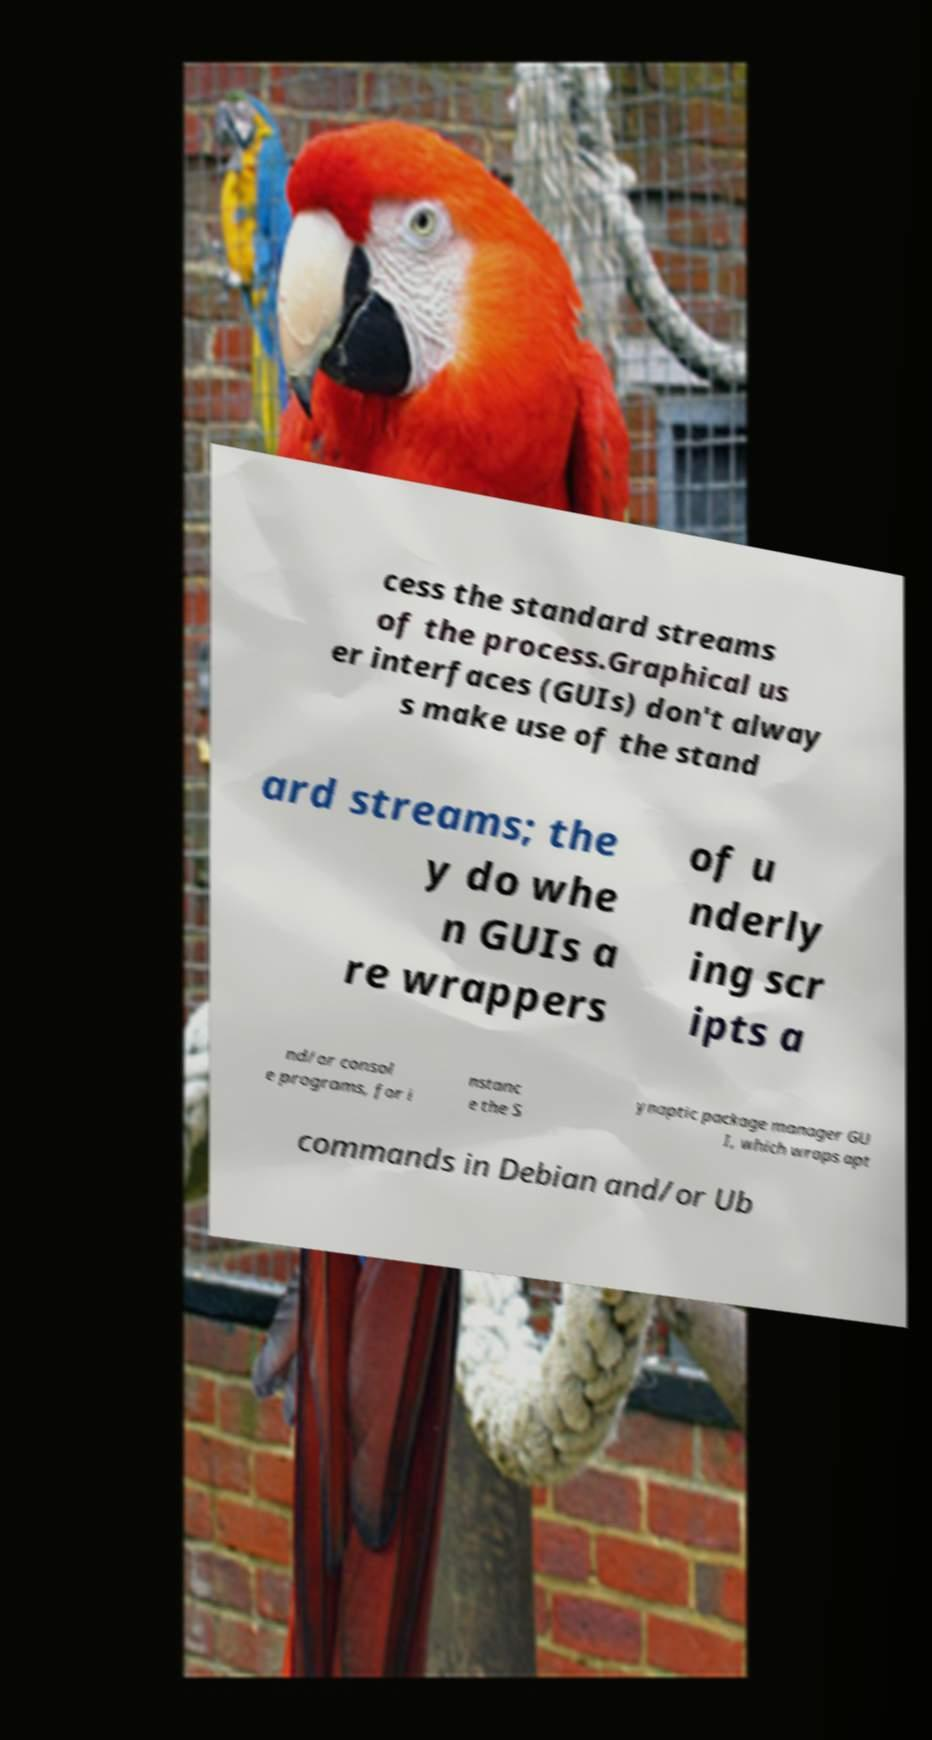What messages or text are displayed in this image? I need them in a readable, typed format. cess the standard streams of the process.Graphical us er interfaces (GUIs) don't alway s make use of the stand ard streams; the y do whe n GUIs a re wrappers of u nderly ing scr ipts a nd/or consol e programs, for i nstanc e the S ynaptic package manager GU I, which wraps apt commands in Debian and/or Ub 